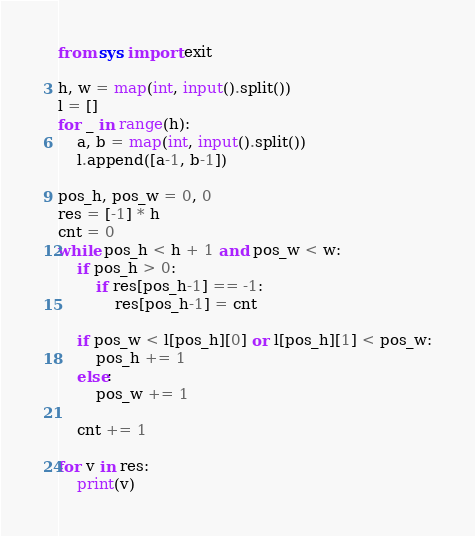<code> <loc_0><loc_0><loc_500><loc_500><_Python_>from sys import exit

h, w = map(int, input().split())
l = []
for _ in range(h):
    a, b = map(int, input().split())
    l.append([a-1, b-1])

pos_h, pos_w = 0, 0
res = [-1] * h
cnt = 0
while pos_h < h + 1 and pos_w < w:
    if pos_h > 0:
        if res[pos_h-1] == -1:
            res[pos_h-1] = cnt

    if pos_w < l[pos_h][0] or l[pos_h][1] < pos_w:
        pos_h += 1
    else:
        pos_w += 1
    
    cnt += 1

for v in res:
    print(v)</code> 